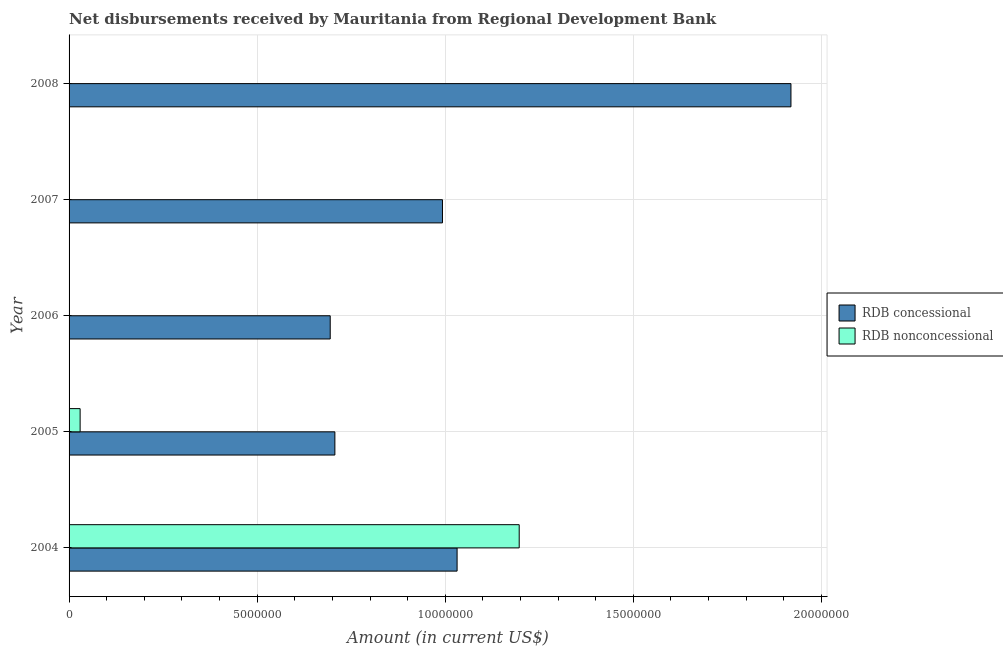Are the number of bars per tick equal to the number of legend labels?
Give a very brief answer. No. How many bars are there on the 4th tick from the top?
Keep it short and to the point. 2. What is the label of the 1st group of bars from the top?
Make the answer very short. 2008. In how many cases, is the number of bars for a given year not equal to the number of legend labels?
Ensure brevity in your answer.  3. What is the net concessional disbursements from rdb in 2008?
Provide a succinct answer. 1.92e+07. Across all years, what is the maximum net concessional disbursements from rdb?
Give a very brief answer. 1.92e+07. In which year was the net non concessional disbursements from rdb maximum?
Your response must be concise. 2004. What is the total net non concessional disbursements from rdb in the graph?
Keep it short and to the point. 1.23e+07. What is the difference between the net concessional disbursements from rdb in 2006 and that in 2007?
Your answer should be very brief. -2.98e+06. What is the difference between the net non concessional disbursements from rdb in 2005 and the net concessional disbursements from rdb in 2007?
Offer a terse response. -9.63e+06. What is the average net concessional disbursements from rdb per year?
Your response must be concise. 1.07e+07. In the year 2005, what is the difference between the net non concessional disbursements from rdb and net concessional disbursements from rdb?
Ensure brevity in your answer.  -6.77e+06. In how many years, is the net concessional disbursements from rdb greater than 15000000 US$?
Give a very brief answer. 1. What is the ratio of the net concessional disbursements from rdb in 2005 to that in 2006?
Give a very brief answer. 1.02. Is the net concessional disbursements from rdb in 2005 less than that in 2007?
Ensure brevity in your answer.  Yes. What is the difference between the highest and the second highest net concessional disbursements from rdb?
Your response must be concise. 8.88e+06. What is the difference between the highest and the lowest net concessional disbursements from rdb?
Ensure brevity in your answer.  1.22e+07. Is the sum of the net concessional disbursements from rdb in 2006 and 2007 greater than the maximum net non concessional disbursements from rdb across all years?
Offer a terse response. Yes. How many bars are there?
Your answer should be very brief. 7. Are the values on the major ticks of X-axis written in scientific E-notation?
Your response must be concise. No. Where does the legend appear in the graph?
Provide a succinct answer. Center right. How many legend labels are there?
Give a very brief answer. 2. What is the title of the graph?
Offer a terse response. Net disbursements received by Mauritania from Regional Development Bank. What is the label or title of the X-axis?
Provide a short and direct response. Amount (in current US$). What is the Amount (in current US$) in RDB concessional in 2004?
Your answer should be very brief. 1.03e+07. What is the Amount (in current US$) of RDB nonconcessional in 2004?
Provide a succinct answer. 1.20e+07. What is the Amount (in current US$) in RDB concessional in 2005?
Provide a short and direct response. 7.07e+06. What is the Amount (in current US$) of RDB nonconcessional in 2005?
Offer a terse response. 2.94e+05. What is the Amount (in current US$) of RDB concessional in 2006?
Provide a succinct answer. 6.94e+06. What is the Amount (in current US$) of RDB nonconcessional in 2006?
Offer a terse response. 0. What is the Amount (in current US$) of RDB concessional in 2007?
Keep it short and to the point. 9.93e+06. What is the Amount (in current US$) in RDB nonconcessional in 2007?
Your answer should be compact. 0. What is the Amount (in current US$) of RDB concessional in 2008?
Your answer should be compact. 1.92e+07. What is the Amount (in current US$) of RDB nonconcessional in 2008?
Provide a short and direct response. 0. Across all years, what is the maximum Amount (in current US$) in RDB concessional?
Offer a terse response. 1.92e+07. Across all years, what is the maximum Amount (in current US$) in RDB nonconcessional?
Provide a short and direct response. 1.20e+07. Across all years, what is the minimum Amount (in current US$) in RDB concessional?
Keep it short and to the point. 6.94e+06. What is the total Amount (in current US$) of RDB concessional in the graph?
Ensure brevity in your answer.  5.34e+07. What is the total Amount (in current US$) in RDB nonconcessional in the graph?
Your response must be concise. 1.23e+07. What is the difference between the Amount (in current US$) of RDB concessional in 2004 and that in 2005?
Offer a terse response. 3.25e+06. What is the difference between the Amount (in current US$) in RDB nonconcessional in 2004 and that in 2005?
Provide a succinct answer. 1.17e+07. What is the difference between the Amount (in current US$) of RDB concessional in 2004 and that in 2006?
Your answer should be very brief. 3.37e+06. What is the difference between the Amount (in current US$) in RDB concessional in 2004 and that in 2007?
Provide a succinct answer. 3.89e+05. What is the difference between the Amount (in current US$) in RDB concessional in 2004 and that in 2008?
Offer a terse response. -8.88e+06. What is the difference between the Amount (in current US$) of RDB concessional in 2005 and that in 2006?
Provide a succinct answer. 1.24e+05. What is the difference between the Amount (in current US$) in RDB concessional in 2005 and that in 2007?
Give a very brief answer. -2.86e+06. What is the difference between the Amount (in current US$) of RDB concessional in 2005 and that in 2008?
Your answer should be compact. -1.21e+07. What is the difference between the Amount (in current US$) in RDB concessional in 2006 and that in 2007?
Offer a terse response. -2.98e+06. What is the difference between the Amount (in current US$) in RDB concessional in 2006 and that in 2008?
Make the answer very short. -1.22e+07. What is the difference between the Amount (in current US$) in RDB concessional in 2007 and that in 2008?
Your response must be concise. -9.26e+06. What is the difference between the Amount (in current US$) of RDB concessional in 2004 and the Amount (in current US$) of RDB nonconcessional in 2005?
Ensure brevity in your answer.  1.00e+07. What is the average Amount (in current US$) in RDB concessional per year?
Give a very brief answer. 1.07e+07. What is the average Amount (in current US$) in RDB nonconcessional per year?
Your response must be concise. 2.45e+06. In the year 2004, what is the difference between the Amount (in current US$) of RDB concessional and Amount (in current US$) of RDB nonconcessional?
Keep it short and to the point. -1.65e+06. In the year 2005, what is the difference between the Amount (in current US$) of RDB concessional and Amount (in current US$) of RDB nonconcessional?
Provide a short and direct response. 6.77e+06. What is the ratio of the Amount (in current US$) in RDB concessional in 2004 to that in 2005?
Offer a very short reply. 1.46. What is the ratio of the Amount (in current US$) of RDB nonconcessional in 2004 to that in 2005?
Your response must be concise. 40.7. What is the ratio of the Amount (in current US$) in RDB concessional in 2004 to that in 2006?
Offer a very short reply. 1.49. What is the ratio of the Amount (in current US$) in RDB concessional in 2004 to that in 2007?
Offer a very short reply. 1.04. What is the ratio of the Amount (in current US$) in RDB concessional in 2004 to that in 2008?
Ensure brevity in your answer.  0.54. What is the ratio of the Amount (in current US$) of RDB concessional in 2005 to that in 2006?
Provide a short and direct response. 1.02. What is the ratio of the Amount (in current US$) of RDB concessional in 2005 to that in 2007?
Offer a very short reply. 0.71. What is the ratio of the Amount (in current US$) of RDB concessional in 2005 to that in 2008?
Your response must be concise. 0.37. What is the ratio of the Amount (in current US$) of RDB concessional in 2006 to that in 2007?
Your answer should be compact. 0.7. What is the ratio of the Amount (in current US$) of RDB concessional in 2006 to that in 2008?
Offer a very short reply. 0.36. What is the ratio of the Amount (in current US$) in RDB concessional in 2007 to that in 2008?
Keep it short and to the point. 0.52. What is the difference between the highest and the second highest Amount (in current US$) of RDB concessional?
Give a very brief answer. 8.88e+06. What is the difference between the highest and the lowest Amount (in current US$) of RDB concessional?
Provide a succinct answer. 1.22e+07. What is the difference between the highest and the lowest Amount (in current US$) in RDB nonconcessional?
Offer a terse response. 1.20e+07. 